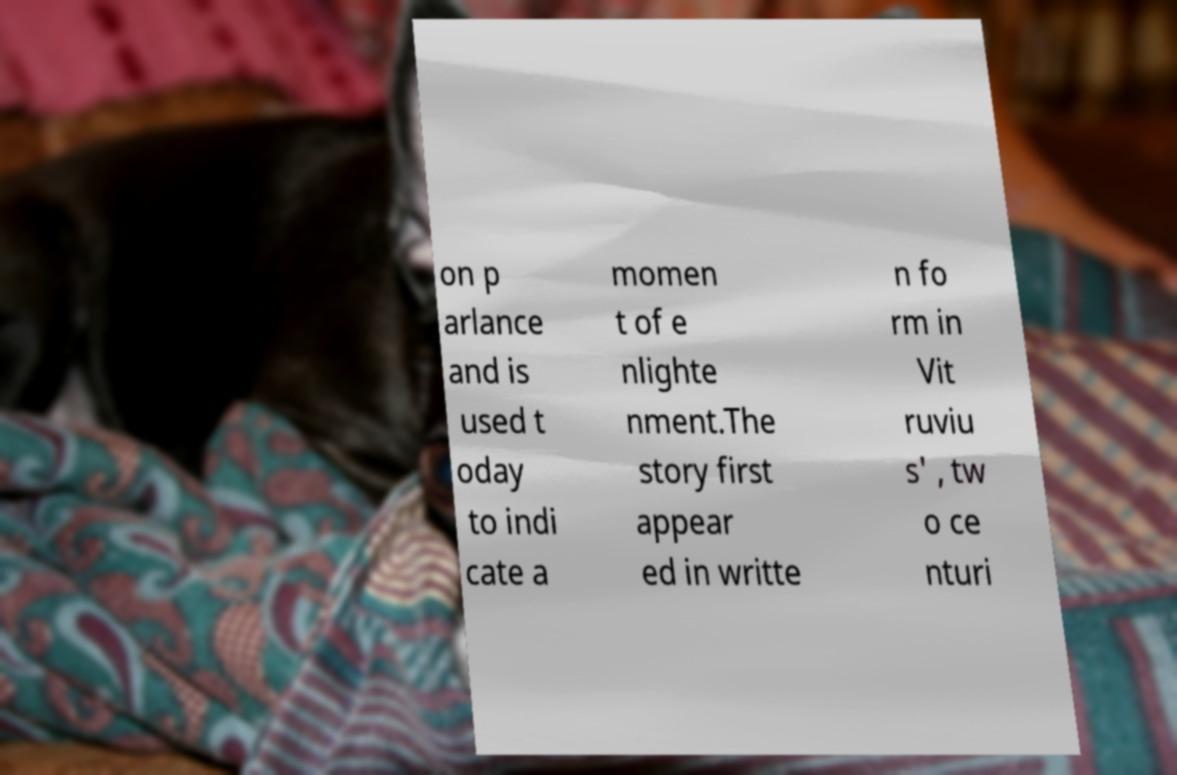Can you accurately transcribe the text from the provided image for me? on p arlance and is used t oday to indi cate a momen t of e nlighte nment.The story first appear ed in writte n fo rm in Vit ruviu s' , tw o ce nturi 